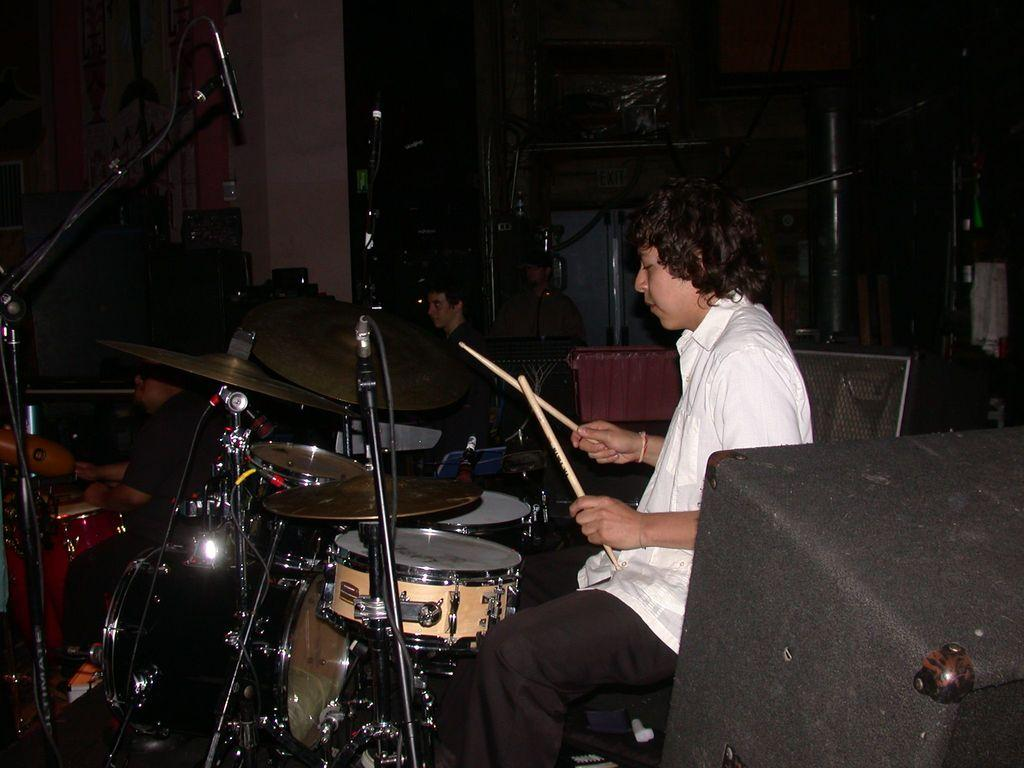What is the man in the image doing? The man is playing drums in the image. How is the man playing the drums? The man is using drum sticks to play the drums. Are there any other people in the image? Yes, there are people seated on the side in the image. What is the position of the man in the image? The man is seated while playing the drums. What type of flag is being waved by the man in the image? There is no flag present in the image; the man is playing drums. What is being served for dinner in the image? There is no mention of dinner in the image; it features a man playing drums and people seated on the side. 